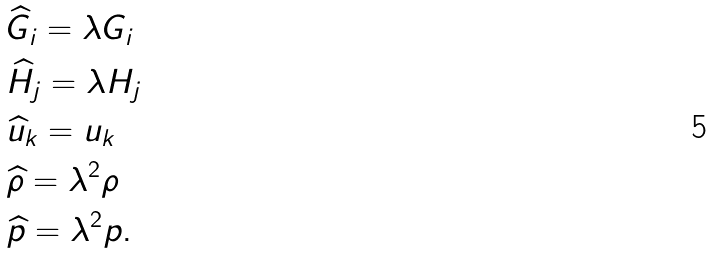<formula> <loc_0><loc_0><loc_500><loc_500>& \widehat { G } _ { i } = \lambda G _ { i } \\ & \widehat { H } _ { j } = \lambda H _ { j } \\ & \widehat { u } _ { k } = u _ { k } \\ & \widehat { \rho } = \lambda ^ { 2 } \rho \\ & \widehat { p } = \lambda ^ { 2 } p .</formula> 